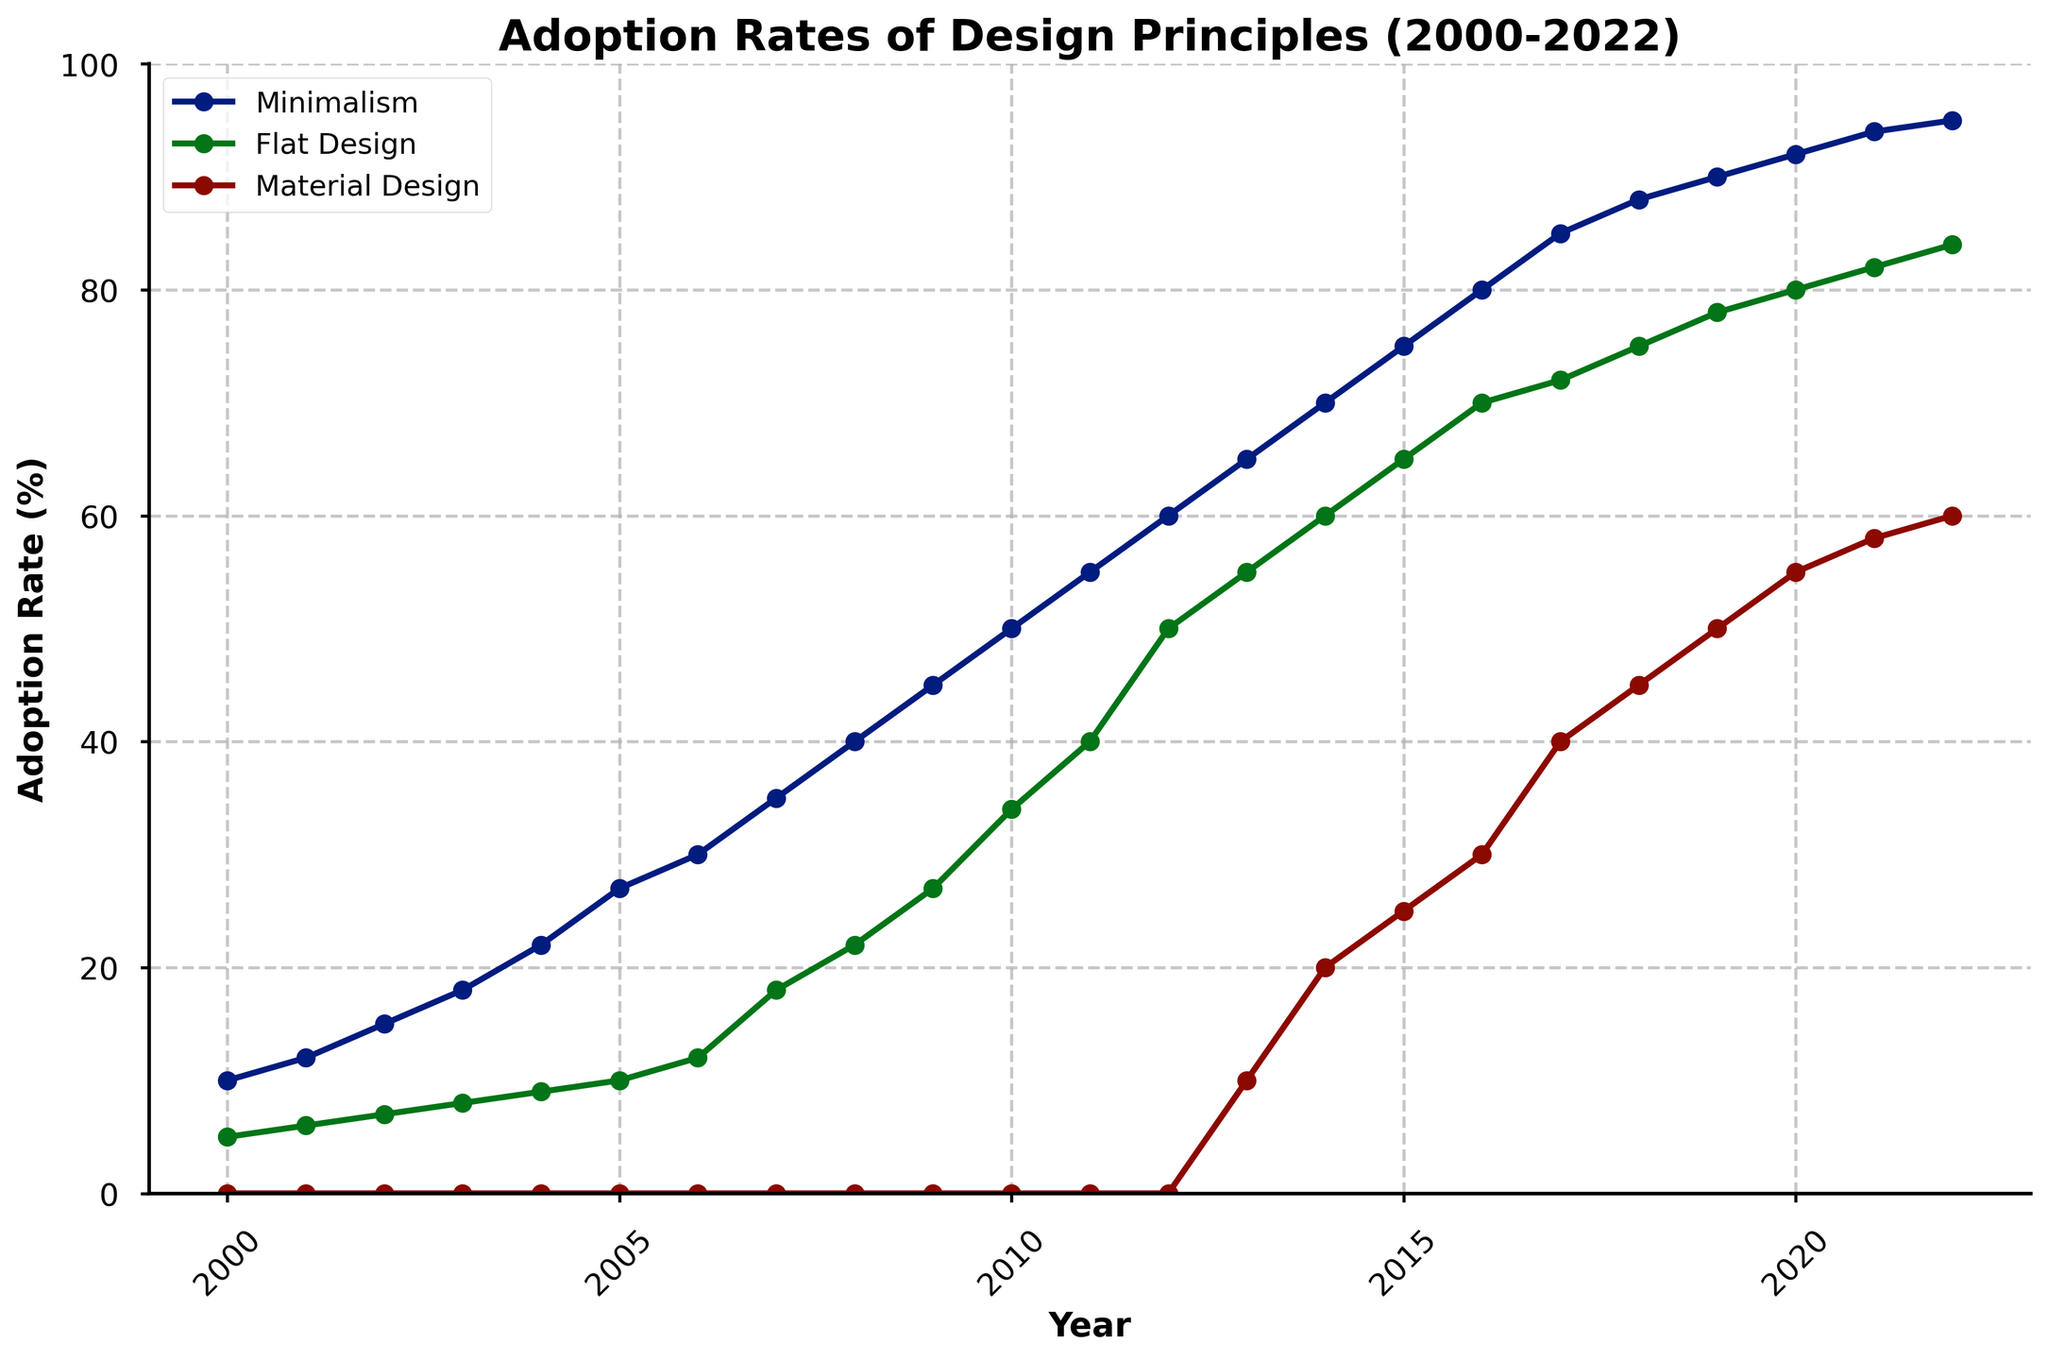What is the title of the plot? The title is usually displayed at the top of the plot. Here, it is given as "Adoption Rates of Design Principles (2000-2022)" in the center.
Answer: Adoption Rates of Design Principles (2000-2022) What is the adoption rate of Minimalism in 2010? Locate the year 2010 on the x-axis, trace upwards to the line corresponding to Minimalism, then read the y-axis value.
Answer: 50 Which design principle had the fastest increase in adoption rate between 2012 and 2014? Look at the slopes of the lines for Minimalism, Flat Design, and Material Design between 2012 and 2014. The steeper the line, the faster the increase.
Answer: Material Design How does the adoption rate of Flat Design in 2007 compare to Material Design in 2017? Locate the year 2007 on the x-axis, trace to Flat Design, and note the y-axis value (18). Repeat for Material Design in 2017 (40). Compare these two values.
Answer: Flat Design is lower What is the average adoption rate of Minimalism across the years 2000 to 2002? Find the adoption rates for Minimalism for 2000 (10), 2001 (12), and 2002 (15). Sum these values and divide by the number of years (3). (10 + 12 + 15) / 3 = 12.33
Answer: 12.33 Which design principle reached a 50% adoption rate first? Identify which line reaches the 50 mark on the y-axis first. Minimalism hits 50% in 2010.
Answer: Minimalism Between what years did Material Design see a consistent increase in its adoption rate? Look at the trend of the Material Design line and find a period with a continuous upward slope. Material Design consistently increased from 2013 onwards.
Answer: 2013-2022 What is the total increase in adoption rate for Flat Design from 2000 to 2022? Locate the value of Flat Design in 2000 (5) and in 2022 (84). Subtract the 2000 value from the 2022 value. 84 - 5 = 79
Answer: 79 In which year did Minimalism adoption rate surpass 60%? Trace the Minimalism line to identify the first year it crosses the 60% mark on the y-axis. This occurs in 2012.
Answer: 2012 What was the most dominant design principle in 2022? Look at the adoption rates for Minimalism (95), Flat Design (84), and Material Design (60) in 2022. Determine which has the highest value.
Answer: Minimalism 